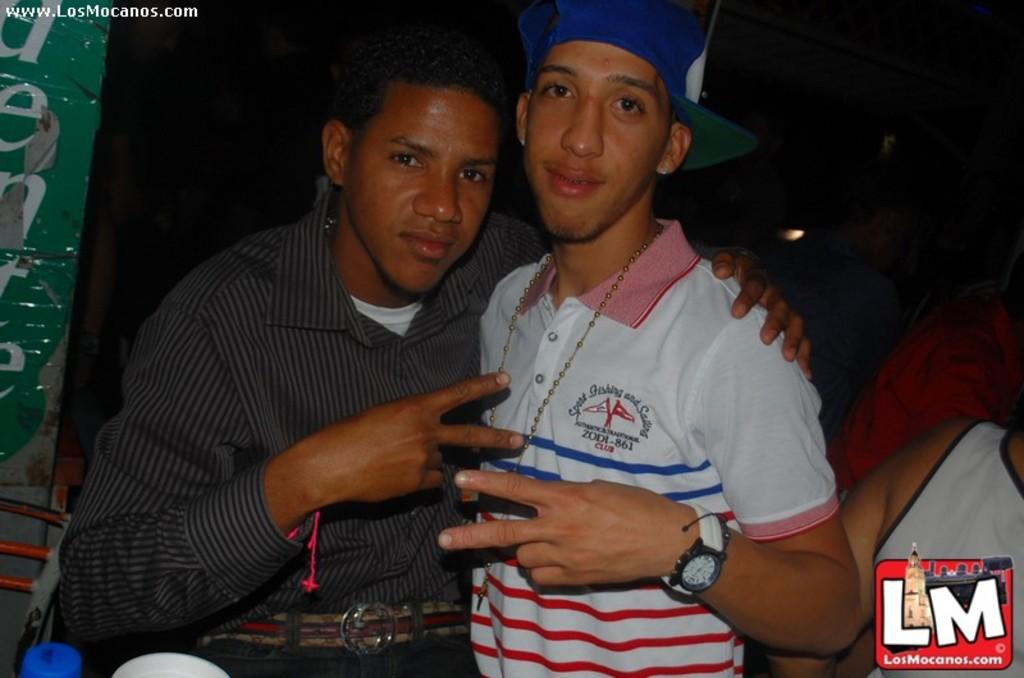<image>
Give a short and clear explanation of the subsequent image. two guys flashing peace signs, one has a shirt with sport fishing and sailing  zodi-861 club on it 